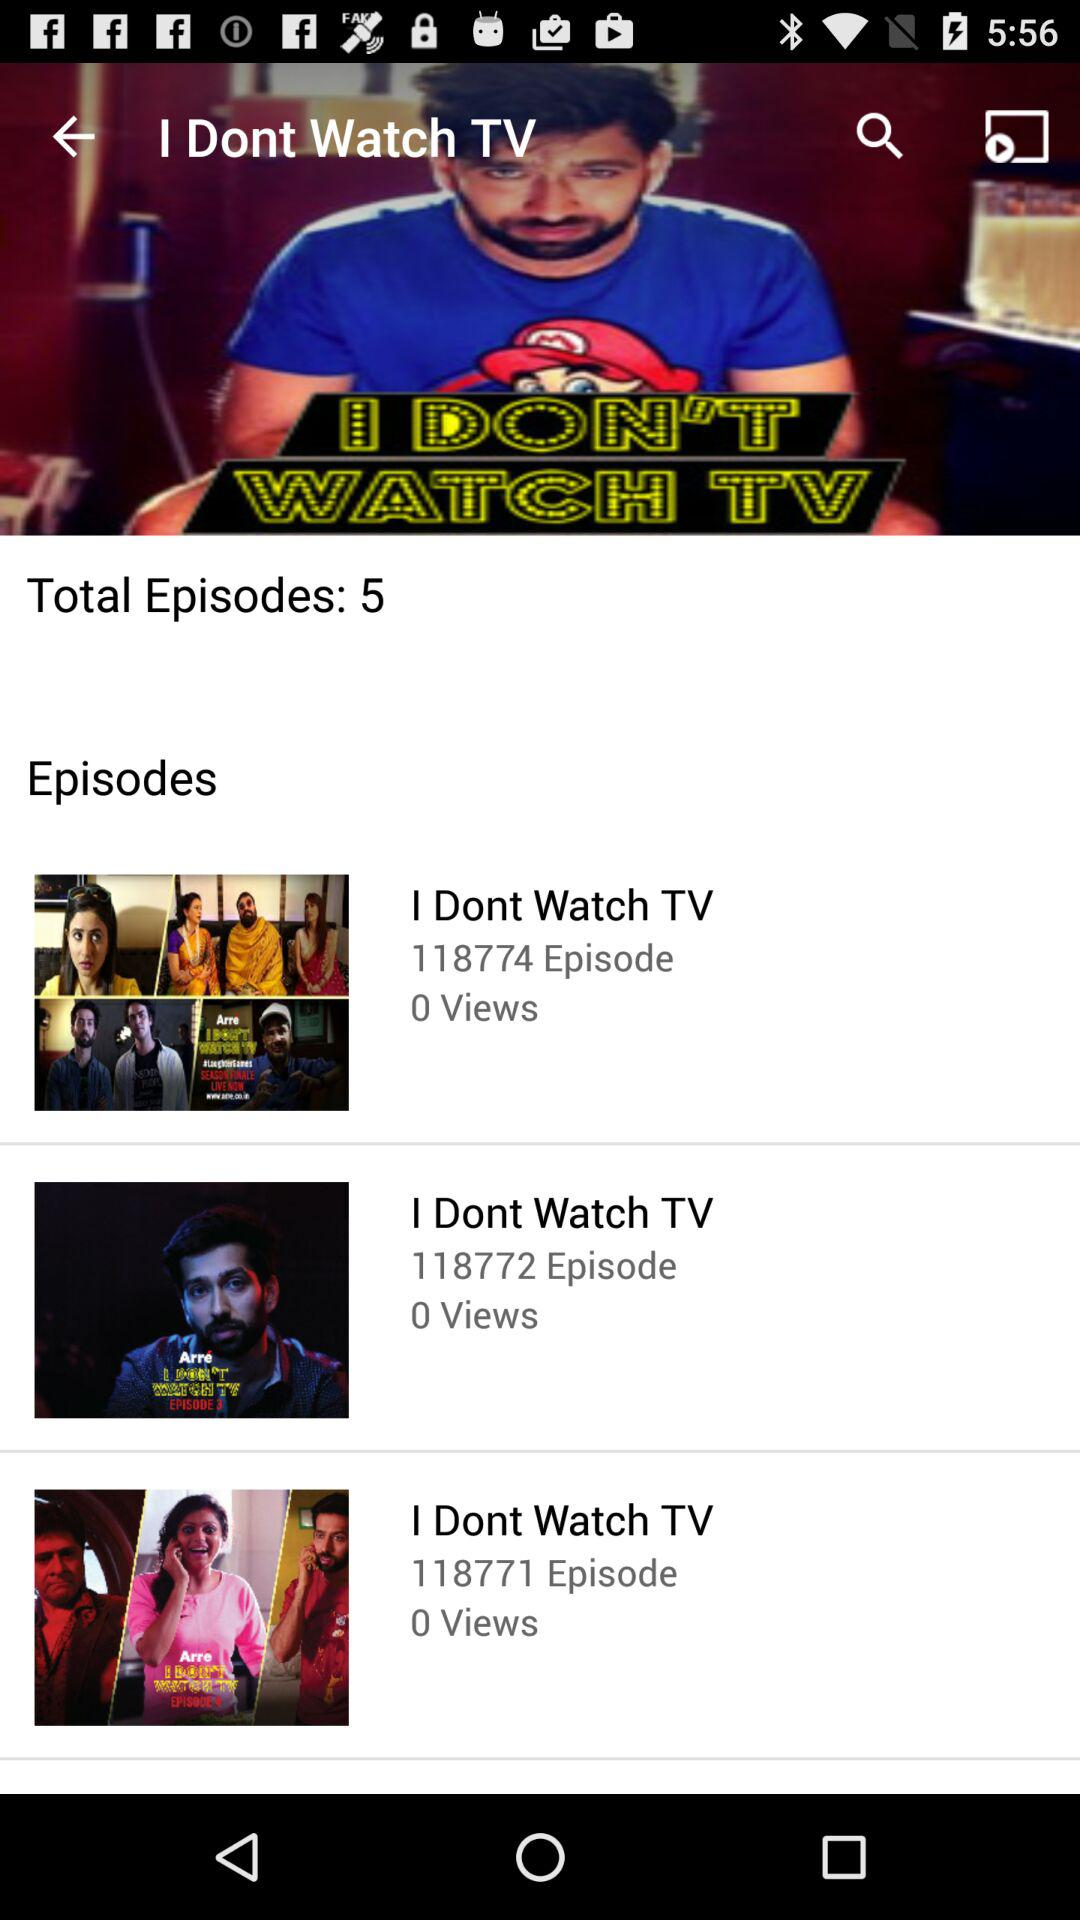How many episodes are there in the show "I DON'T WATCH TV"? There are 5 episodes. 